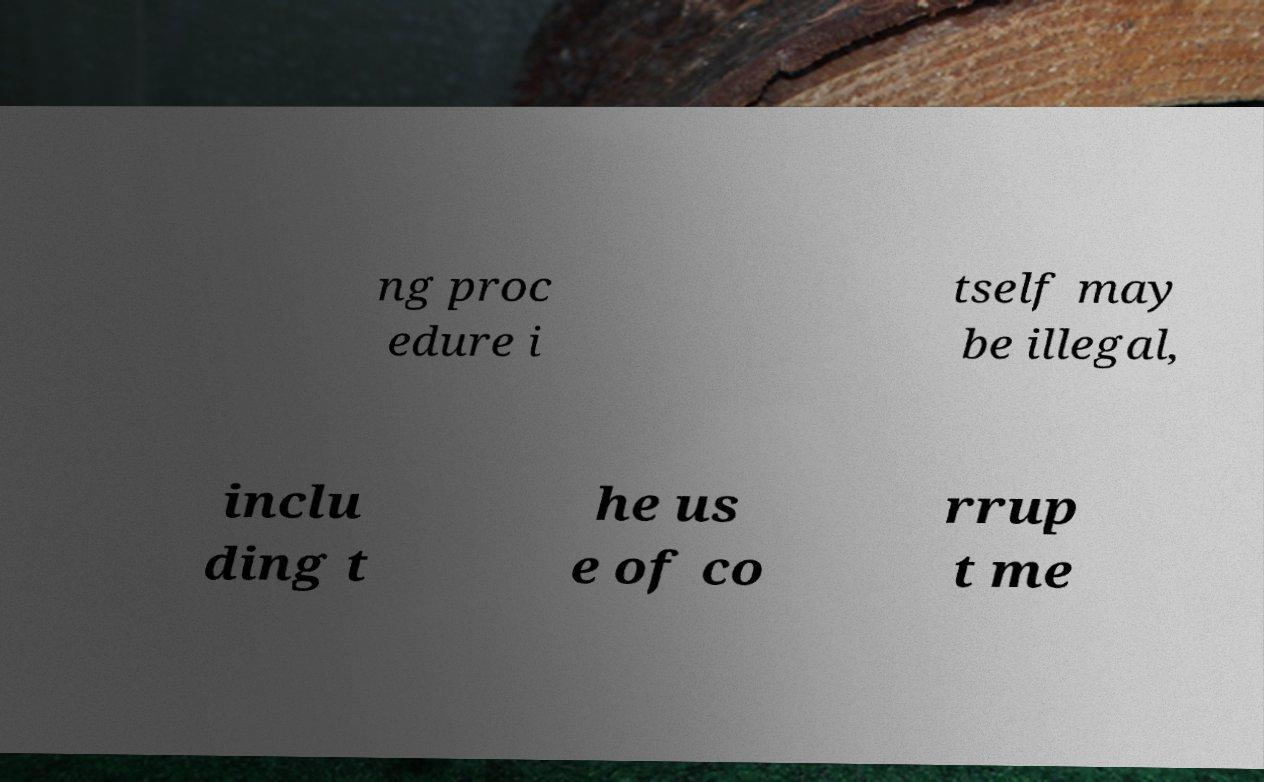Can you accurately transcribe the text from the provided image for me? ng proc edure i tself may be illegal, inclu ding t he us e of co rrup t me 